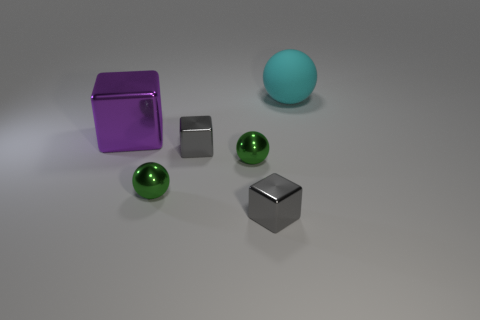Add 1 tiny green balls. How many objects exist? 7 Subtract all tiny red rubber cubes. Subtract all small metal balls. How many objects are left? 4 Add 1 big cyan balls. How many big cyan balls are left? 2 Add 4 big purple things. How many big purple things exist? 5 Subtract 0 brown cylinders. How many objects are left? 6 